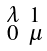Convert formula to latex. <formula><loc_0><loc_0><loc_500><loc_500>\begin{smallmatrix} \lambda & 1 \\ 0 & \mu \end{smallmatrix}</formula> 